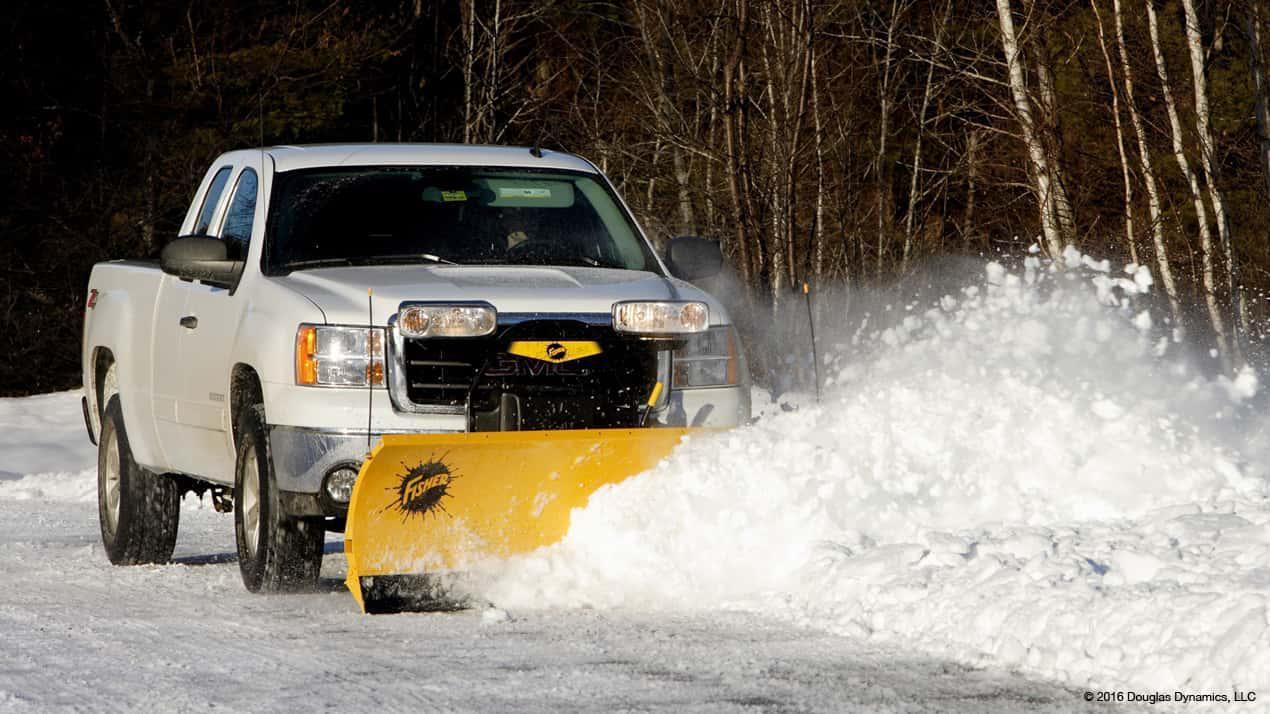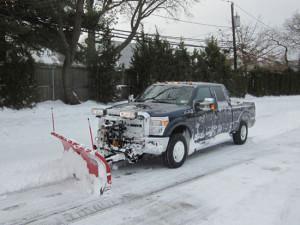The first image is the image on the left, the second image is the image on the right. Considering the images on both sides, is "The scraper in the image on the left is red." valid? Answer yes or no. No. 